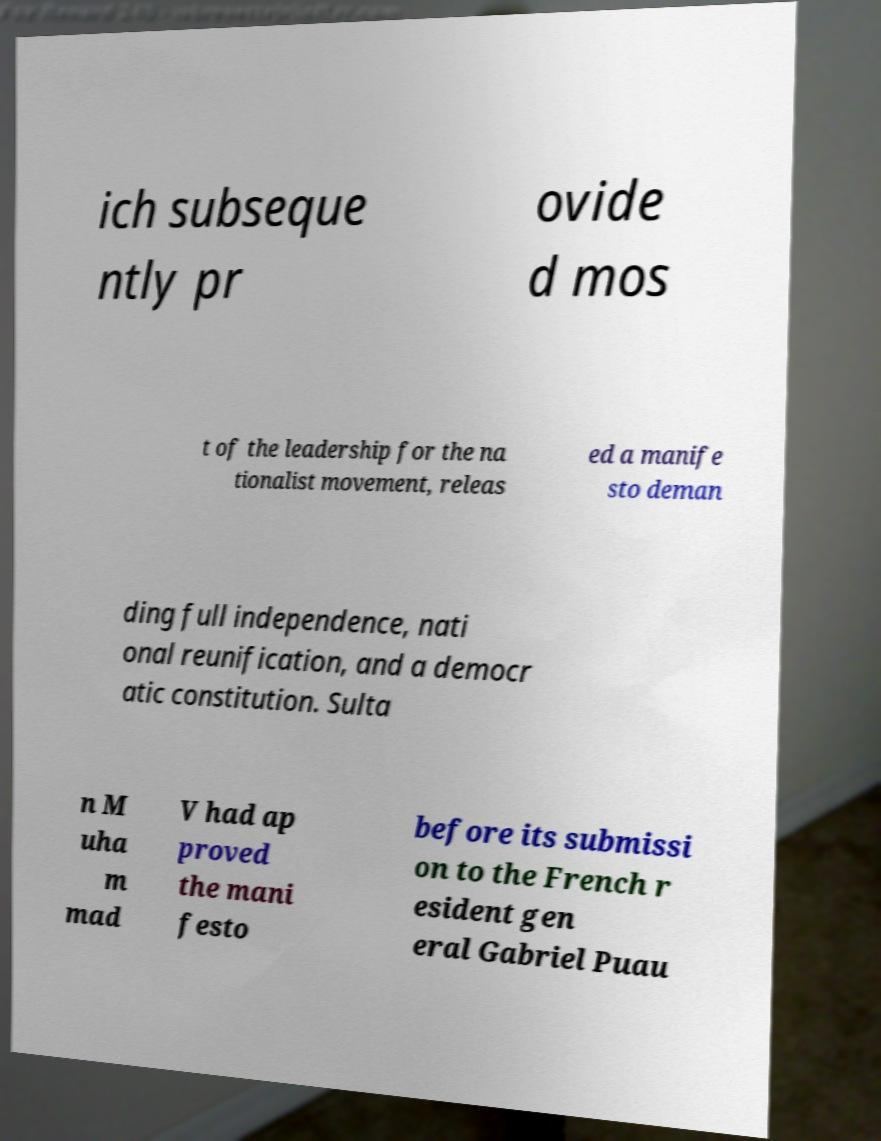For documentation purposes, I need the text within this image transcribed. Could you provide that? ich subseque ntly pr ovide d mos t of the leadership for the na tionalist movement, releas ed a manife sto deman ding full independence, nati onal reunification, and a democr atic constitution. Sulta n M uha m mad V had ap proved the mani festo before its submissi on to the French r esident gen eral Gabriel Puau 